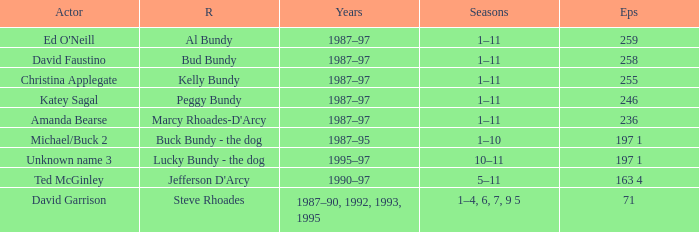How many episodes did the actor David Faustino appear in? 258.0. 